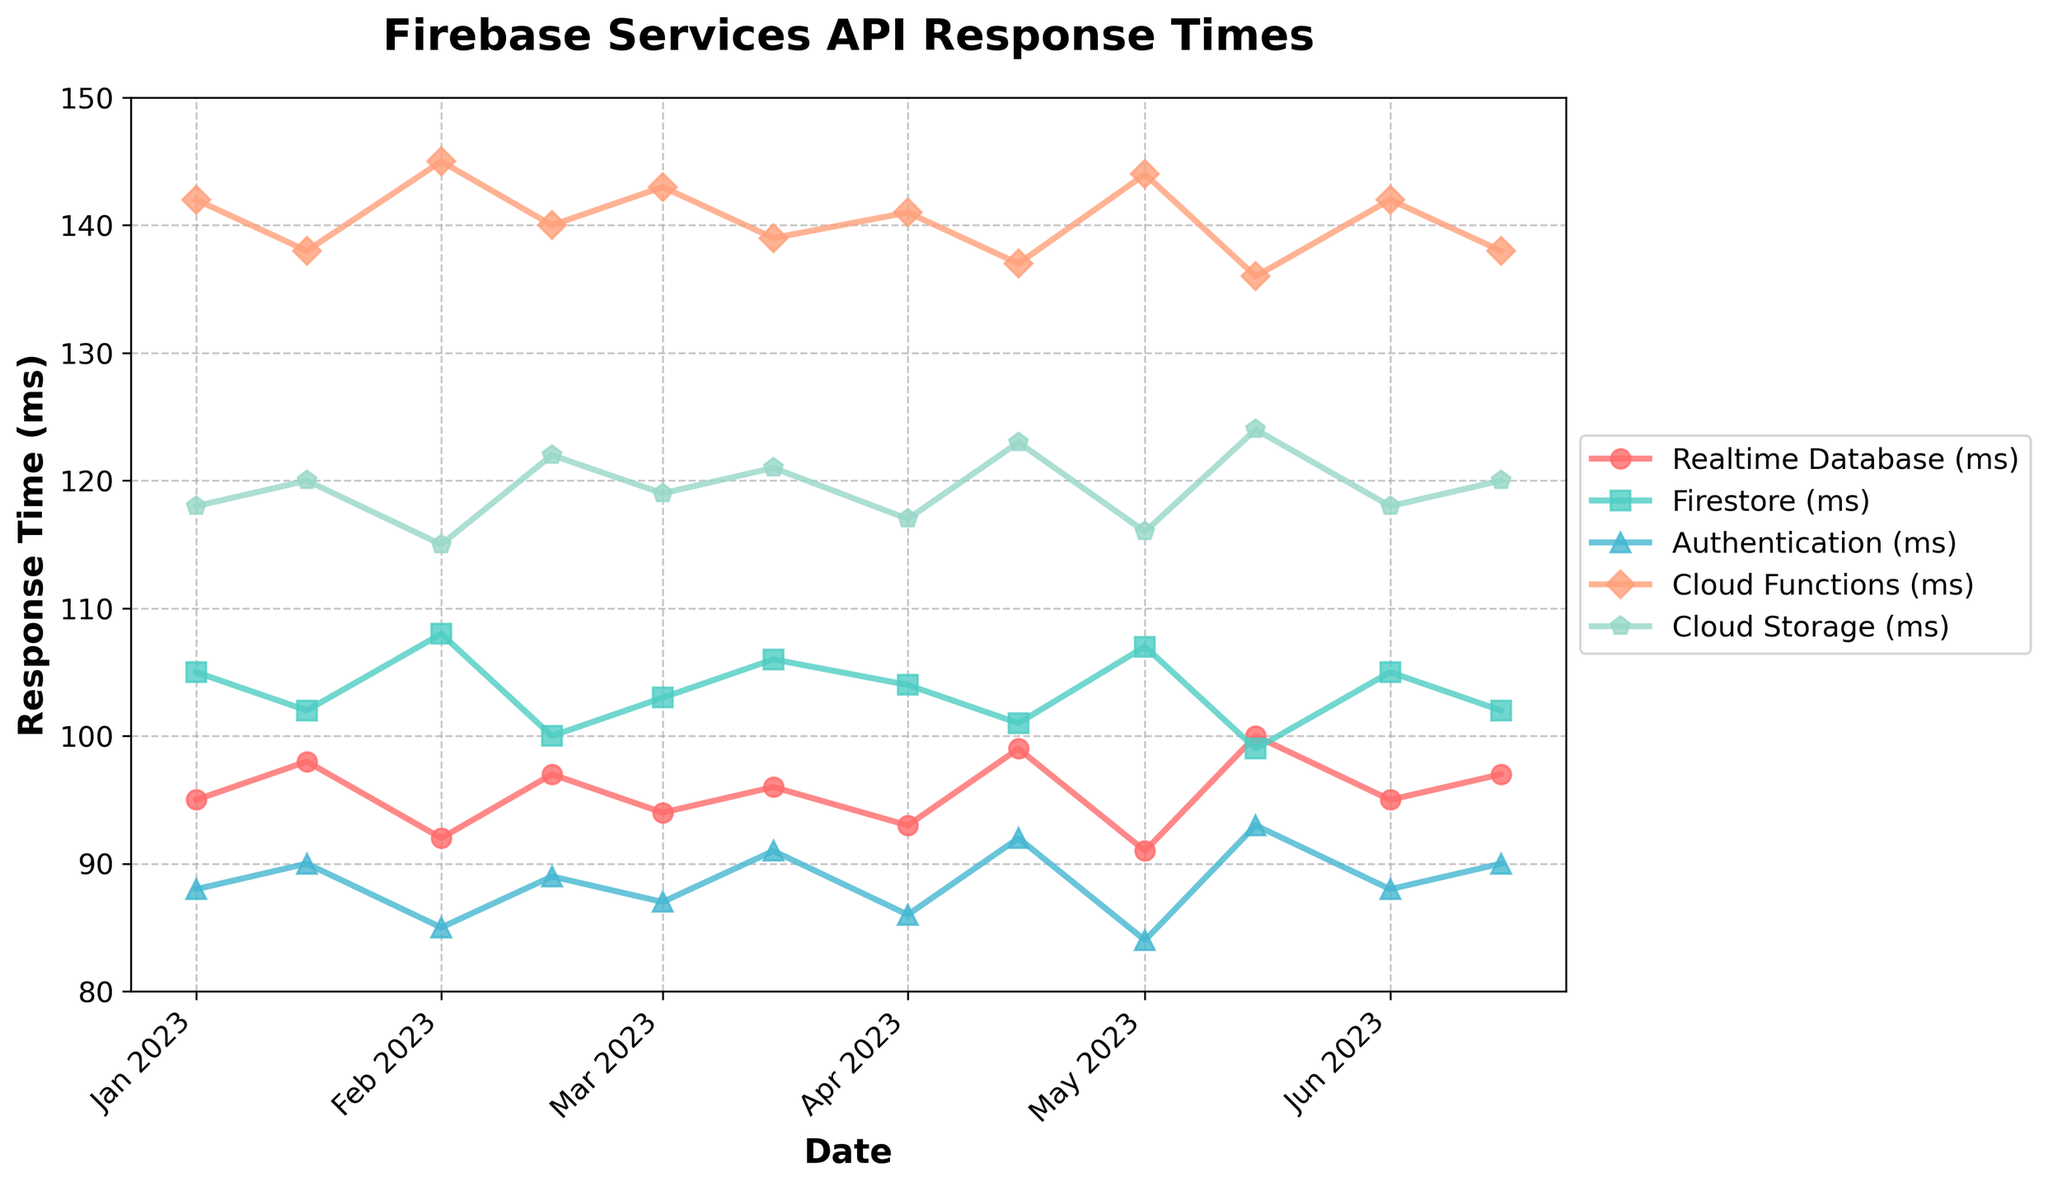When did the Realtime Database and Firestore have their closest response times? To answer this, we need to look for the smallest gap between the response times of Realtime Database and Firestore across all dates. The closest response times are on 2023-02-15, with Realtime Database at 97 ms and Firestore at 100 ms, giving a difference of 3 ms.
Answer: 2023-02-15 Which month had the highest average response time for Cloud Functions? First, sum the response times for Cloud Functions within each month and then divide by the number of data points in that month. March has the highest average response time of 141.0 ms ((143+139)/2).
Answer: March What is the average response time for all services in January 2023? Add the response times for all services in January and divide by the number of services. Sum: 95 + 105 + 88 + 142 + 118 = 548, divided by 5 services gives 109.6 ms.
Answer: 109.6 ms Which service had the smallest overall change in response time over the 6-month period? Calculate the difference between the highest and lowest response times for each service over the 6 months. Overall, Firestore had the smallest change, ranging from 99 ms to 108 ms (9 ms difference).
Answer: Firestore Between Realtime Database and Authentication, which service showed more consistency in response times? To measure consistency, compare the range (difference between the maximum and minimum response times) for each service. Realtime Database's range: 100 - 91 = 9 ms, Authentication's range: 93 - 84 = 9 ms. Both services have the same range, so both are equally consistent.
Answer: Both equally consistent How many times did Cloud Storage's response time exceed 120 ms? Check each date to find instances where Cloud Storage's response time exceeded 120 ms. The instances are: 2023-01-01 (118), 2023-01-15 (120), 2023-02-01 (115), 2023-02-15 (122), 2023-03-01 (119), 2023-03-15 (121), 2023-04-01 (117), 2023-04-15 (123), 2023-05-01 (116), 2023-05-15 (124), 2023-06-01 (118), 2023-06-15 (120). Only 4 dates exceed 120 (2023-02-15, 2023-03-15, 2023-04-15, 2023-05-15).
Answer: 4 On which date did the Authentication service have its lowest response time and what was that time? Check the Authentication response times for all dates to find the lowest value. The lowest response time is on 2023-05-01 with 84 ms response time.
Answer: 2023-05-01, 84 ms 